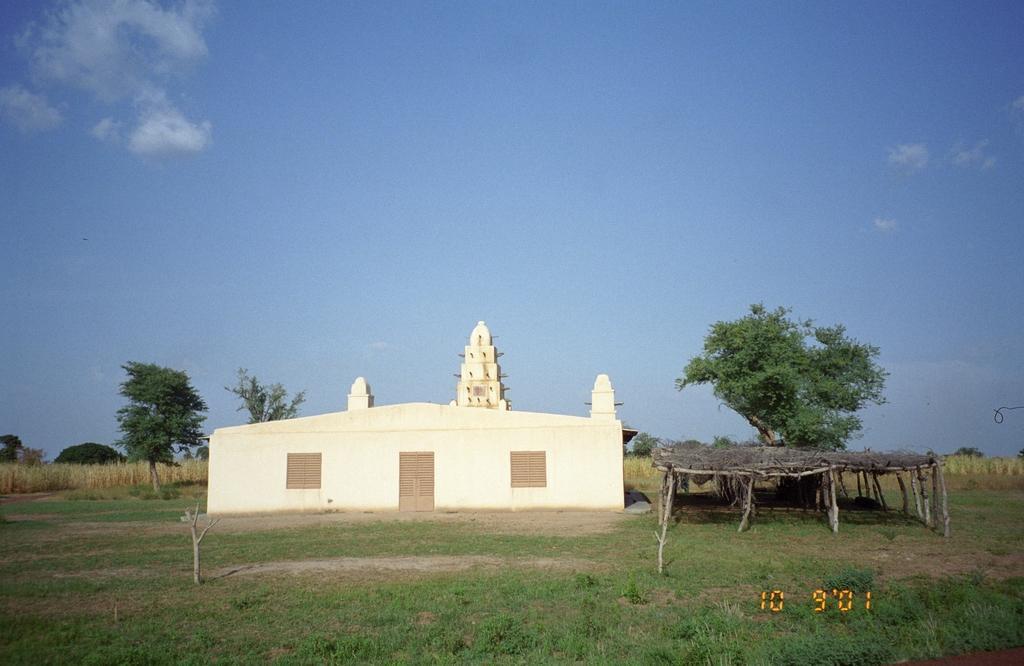Can you describe this image briefly? In this picture there is a small shed house with brown color door and windows. In the front bottom side there is a grass ground. On the right side we can see the straw and bamboo shed. On the top we can see the sky. 